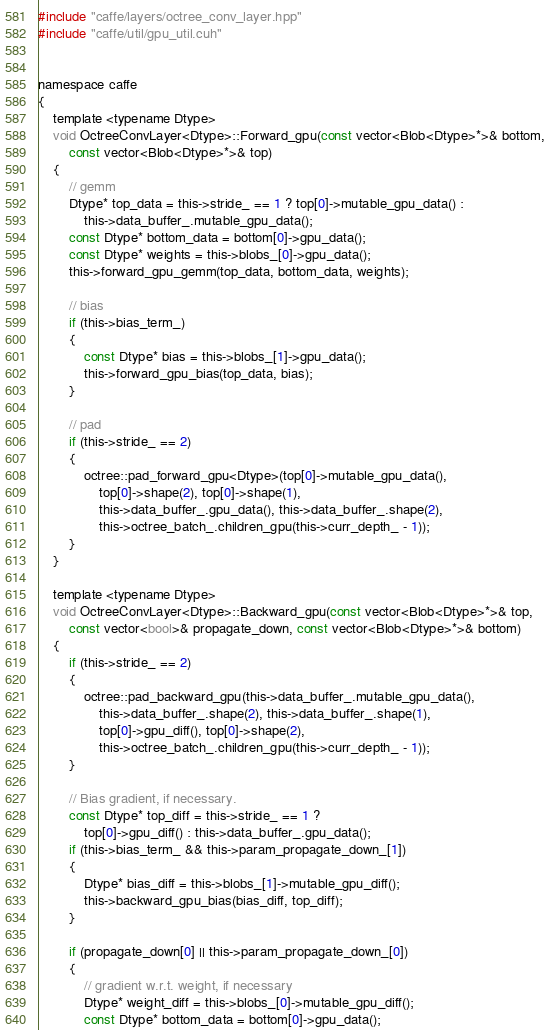Convert code to text. <code><loc_0><loc_0><loc_500><loc_500><_Cuda_>#include "caffe/layers/octree_conv_layer.hpp"
#include "caffe/util/gpu_util.cuh"


namespace caffe
{
	template <typename Dtype>
	void OctreeConvLayer<Dtype>::Forward_gpu(const vector<Blob<Dtype>*>& bottom,
		const vector<Blob<Dtype>*>& top)
	{
		// gemm
		Dtype* top_data = this->stride_ == 1 ? top[0]->mutable_gpu_data() :
			this->data_buffer_.mutable_gpu_data();
		const Dtype* bottom_data = bottom[0]->gpu_data();
		const Dtype* weights = this->blobs_[0]->gpu_data();
		this->forward_gpu_gemm(top_data, bottom_data, weights);

		// bias
		if (this->bias_term_)
		{
			const Dtype* bias = this->blobs_[1]->gpu_data();
			this->forward_gpu_bias(top_data, bias);
		}

		// pad
		if (this->stride_ == 2)
		{
			octree::pad_forward_gpu<Dtype>(top[0]->mutable_gpu_data(),
				top[0]->shape(2), top[0]->shape(1),
				this->data_buffer_.gpu_data(), this->data_buffer_.shape(2),
				this->octree_batch_.children_gpu(this->curr_depth_ - 1));
		}
	}

	template <typename Dtype>
	void OctreeConvLayer<Dtype>::Backward_gpu(const vector<Blob<Dtype>*>& top,
		const vector<bool>& propagate_down, const vector<Blob<Dtype>*>& bottom)
	{
		if (this->stride_ == 2)
		{
			octree::pad_backward_gpu(this->data_buffer_.mutable_gpu_data(),
				this->data_buffer_.shape(2), this->data_buffer_.shape(1),
				top[0]->gpu_diff(), top[0]->shape(2),
				this->octree_batch_.children_gpu(this->curr_depth_ - 1));
		}

		// Bias gradient, if necessary.
		const Dtype* top_diff = this->stride_ == 1 ?
			top[0]->gpu_diff() : this->data_buffer_.gpu_data();
		if (this->bias_term_ && this->param_propagate_down_[1])
		{
			Dtype* bias_diff = this->blobs_[1]->mutable_gpu_diff();
			this->backward_gpu_bias(bias_diff, top_diff);
		}

		if (propagate_down[0] || this->param_propagate_down_[0])
		{
			// gradient w.r.t. weight, if necessary
			Dtype* weight_diff = this->blobs_[0]->mutable_gpu_diff();
			const Dtype* bottom_data = bottom[0]->gpu_data();</code> 